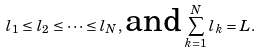Convert formula to latex. <formula><loc_0><loc_0><loc_500><loc_500>l _ { 1 } \leq l _ { 2 } \leq \dots \leq l _ { N } , \, { \text {and} } \, \sum _ { k = 1 } ^ { N } l _ { k } = L .</formula> 